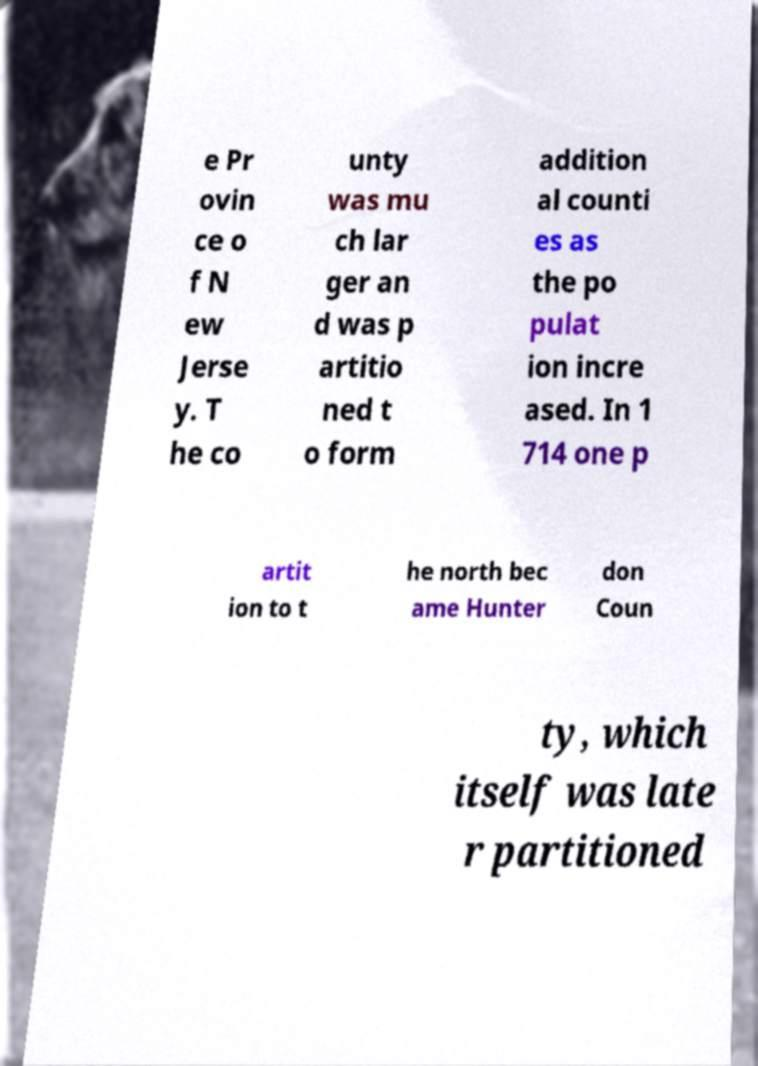Could you assist in decoding the text presented in this image and type it out clearly? e Pr ovin ce o f N ew Jerse y. T he co unty was mu ch lar ger an d was p artitio ned t o form addition al counti es as the po pulat ion incre ased. In 1 714 one p artit ion to t he north bec ame Hunter don Coun ty, which itself was late r partitioned 